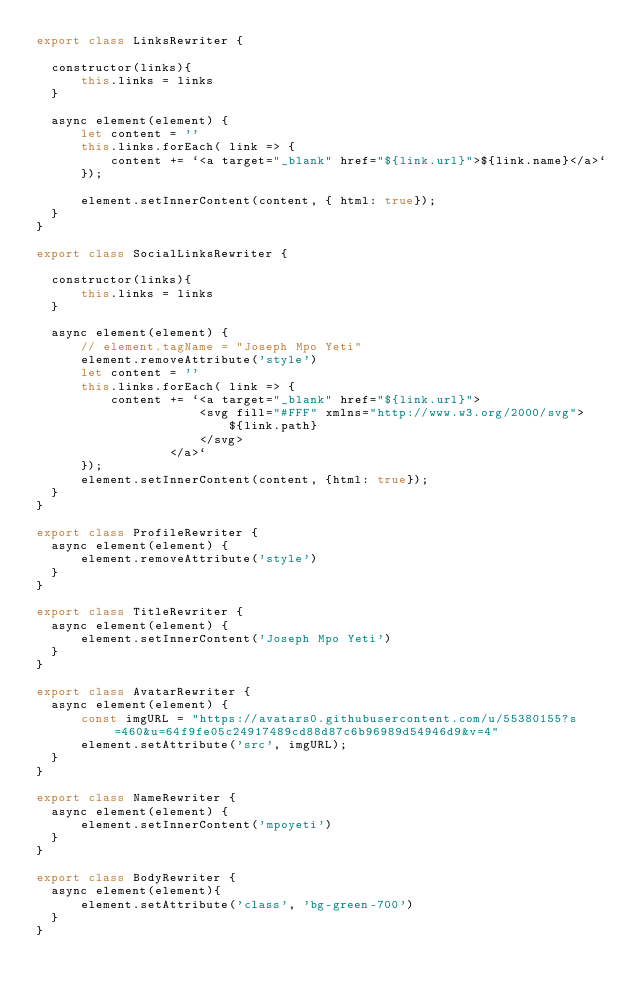<code> <loc_0><loc_0><loc_500><loc_500><_JavaScript_>export class LinksRewriter {
    
  constructor(links){
      this.links = links
  }

  async element(element) {
      let content = ''
      this.links.forEach( link => {
          content += `<a target="_blank" href="${link.url}">${link.name}</a>`
      });

      element.setInnerContent(content, { html: true});
  }
}

export class SocialLinksRewriter {
  
  constructor(links){
      this.links = links
  }

  async element(element) {
      // element.tagName = "Joseph Mpo Yeti"
      element.removeAttribute('style')
      let content = ''
      this.links.forEach( link => {
          content += `<a target="_blank" href="${link.url}">
                      <svg fill="#FFF" xmlns="http://www.w3.org/2000/svg">
                          ${link.path}
                      </svg>
                  </a>`
      });
      element.setInnerContent(content, {html: true});
  }
}

export class ProfileRewriter {
  async element(element) {
      element.removeAttribute('style')
  }
}

export class TitleRewriter {
  async element(element) {
      element.setInnerContent('Joseph Mpo Yeti')
  }
}

export class AvatarRewriter {
  async element(element) {
      const imgURL = "https://avatars0.githubusercontent.com/u/55380155?s=460&u=64f9fe05c24917489cd88d87c6b96989d54946d9&v=4"
      element.setAttribute('src', imgURL);
  }
}

export class NameRewriter {
  async element(element) {
      element.setInnerContent('mpoyeti')
  }
}

export class BodyRewriter {
  async element(element){
      element.setAttribute('class', 'bg-green-700')
  }
}
</code> 